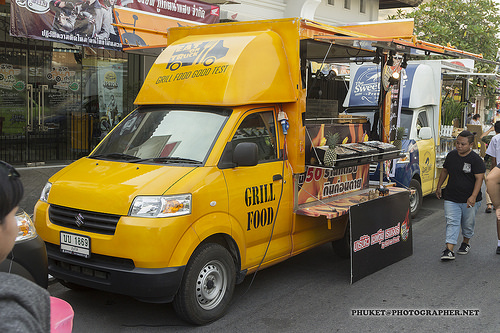<image>
Can you confirm if the truck is behind the pineapple? Yes. From this viewpoint, the truck is positioned behind the pineapple, with the pineapple partially or fully occluding the truck. 